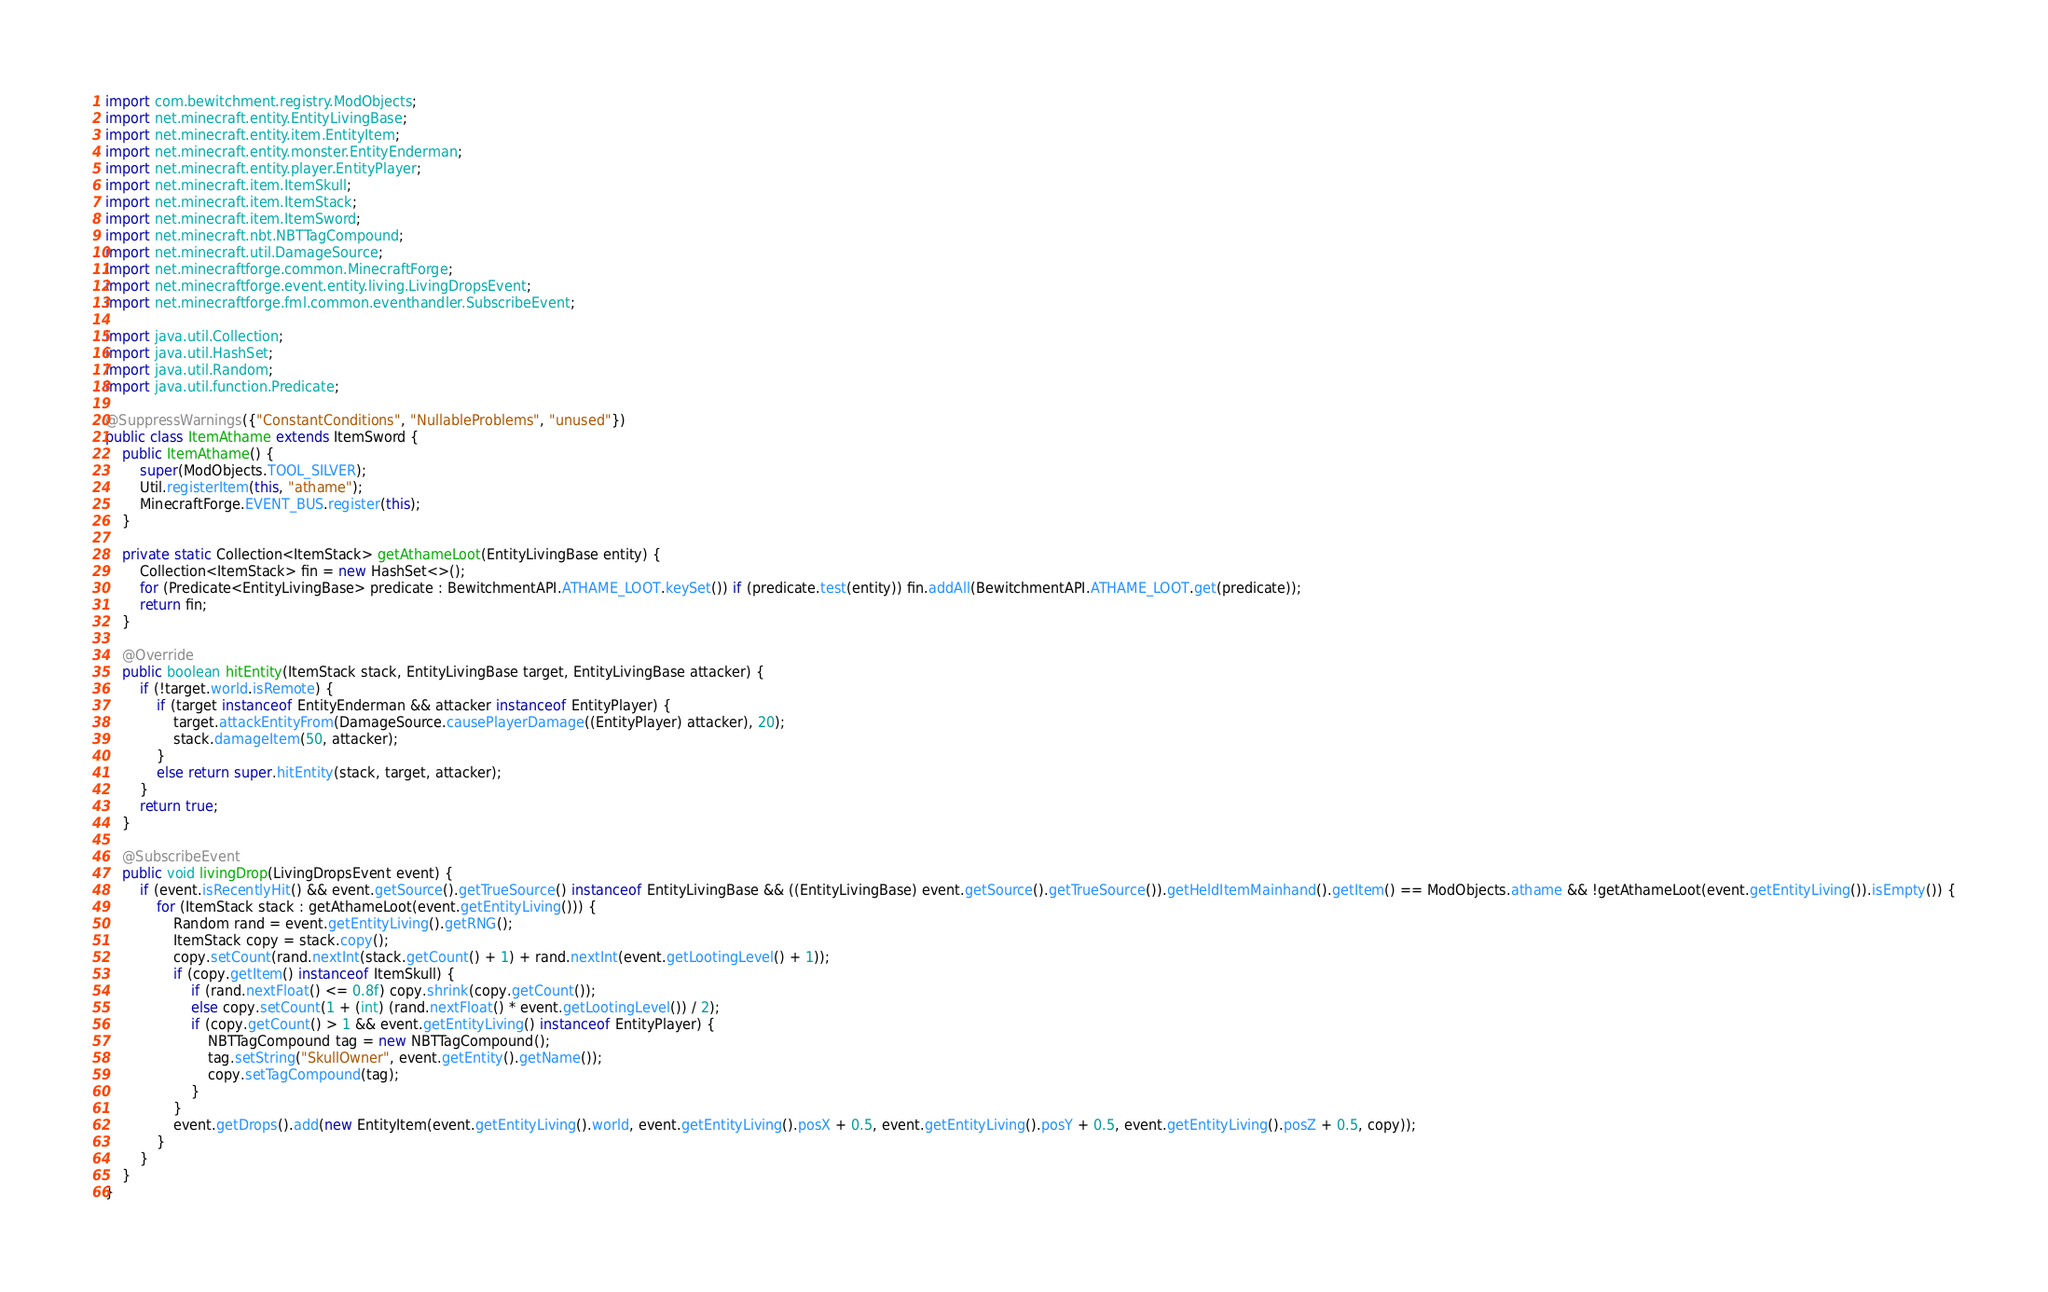<code> <loc_0><loc_0><loc_500><loc_500><_Java_>import com.bewitchment.registry.ModObjects;
import net.minecraft.entity.EntityLivingBase;
import net.minecraft.entity.item.EntityItem;
import net.minecraft.entity.monster.EntityEnderman;
import net.minecraft.entity.player.EntityPlayer;
import net.minecraft.item.ItemSkull;
import net.minecraft.item.ItemStack;
import net.minecraft.item.ItemSword;
import net.minecraft.nbt.NBTTagCompound;
import net.minecraft.util.DamageSource;
import net.minecraftforge.common.MinecraftForge;
import net.minecraftforge.event.entity.living.LivingDropsEvent;
import net.minecraftforge.fml.common.eventhandler.SubscribeEvent;

import java.util.Collection;
import java.util.HashSet;
import java.util.Random;
import java.util.function.Predicate;

@SuppressWarnings({"ConstantConditions", "NullableProblems", "unused"})
public class ItemAthame extends ItemSword {
	public ItemAthame() {
		super(ModObjects.TOOL_SILVER);
		Util.registerItem(this, "athame");
		MinecraftForge.EVENT_BUS.register(this);
	}
	
	private static Collection<ItemStack> getAthameLoot(EntityLivingBase entity) {
		Collection<ItemStack> fin = new HashSet<>();
		for (Predicate<EntityLivingBase> predicate : BewitchmentAPI.ATHAME_LOOT.keySet()) if (predicate.test(entity)) fin.addAll(BewitchmentAPI.ATHAME_LOOT.get(predicate));
		return fin;
	}
	
	@Override
	public boolean hitEntity(ItemStack stack, EntityLivingBase target, EntityLivingBase attacker) {
		if (!target.world.isRemote) {
			if (target instanceof EntityEnderman && attacker instanceof EntityPlayer) {
				target.attackEntityFrom(DamageSource.causePlayerDamage((EntityPlayer) attacker), 20);
				stack.damageItem(50, attacker);
			}
			else return super.hitEntity(stack, target, attacker);
		}
		return true;
	}
	
	@SubscribeEvent
	public void livingDrop(LivingDropsEvent event) {
		if (event.isRecentlyHit() && event.getSource().getTrueSource() instanceof EntityLivingBase && ((EntityLivingBase) event.getSource().getTrueSource()).getHeldItemMainhand().getItem() == ModObjects.athame && !getAthameLoot(event.getEntityLiving()).isEmpty()) {
			for (ItemStack stack : getAthameLoot(event.getEntityLiving())) {
				Random rand = event.getEntityLiving().getRNG();
				ItemStack copy = stack.copy();
				copy.setCount(rand.nextInt(stack.getCount() + 1) + rand.nextInt(event.getLootingLevel() + 1));
				if (copy.getItem() instanceof ItemSkull) {
					if (rand.nextFloat() <= 0.8f) copy.shrink(copy.getCount());
					else copy.setCount(1 + (int) (rand.nextFloat() * event.getLootingLevel()) / 2);
					if (copy.getCount() > 1 && event.getEntityLiving() instanceof EntityPlayer) {
						NBTTagCompound tag = new NBTTagCompound();
						tag.setString("SkullOwner", event.getEntity().getName());
						copy.setTagCompound(tag);
					}
				}
				event.getDrops().add(new EntityItem(event.getEntityLiving().world, event.getEntityLiving().posX + 0.5, event.getEntityLiving().posY + 0.5, event.getEntityLiving().posZ + 0.5, copy));
			}
		}
	}
}</code> 